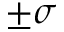<formula> <loc_0><loc_0><loc_500><loc_500>\pm \sigma</formula> 